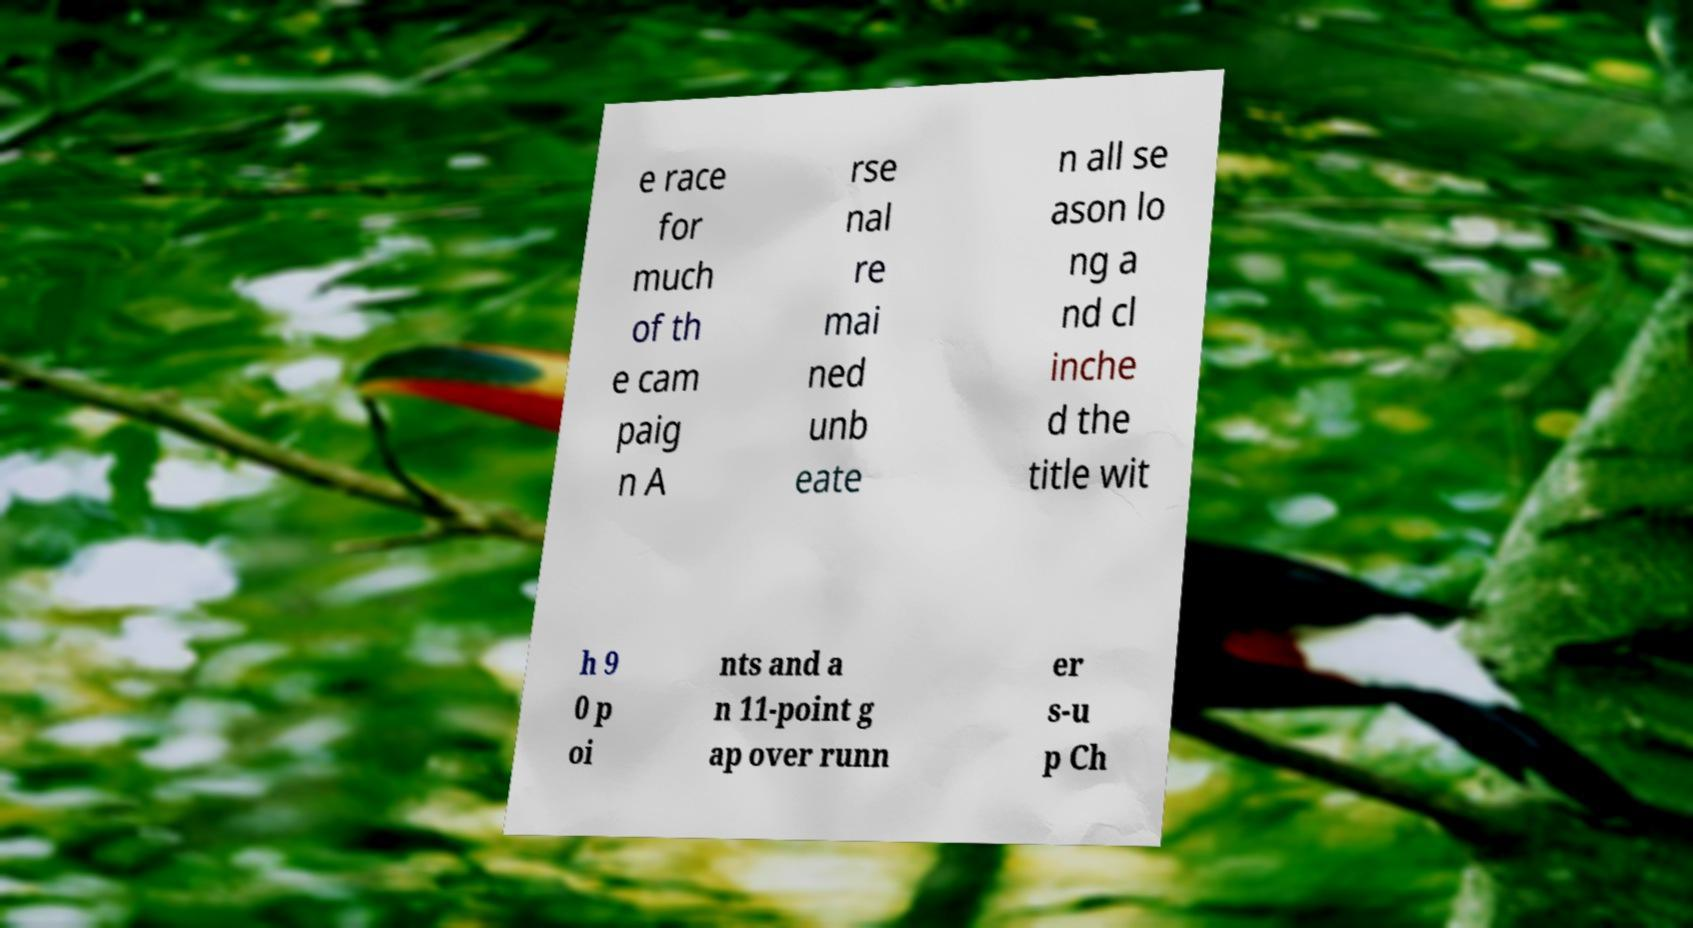What messages or text are displayed in this image? I need them in a readable, typed format. e race for much of th e cam paig n A rse nal re mai ned unb eate n all se ason lo ng a nd cl inche d the title wit h 9 0 p oi nts and a n 11-point g ap over runn er s-u p Ch 